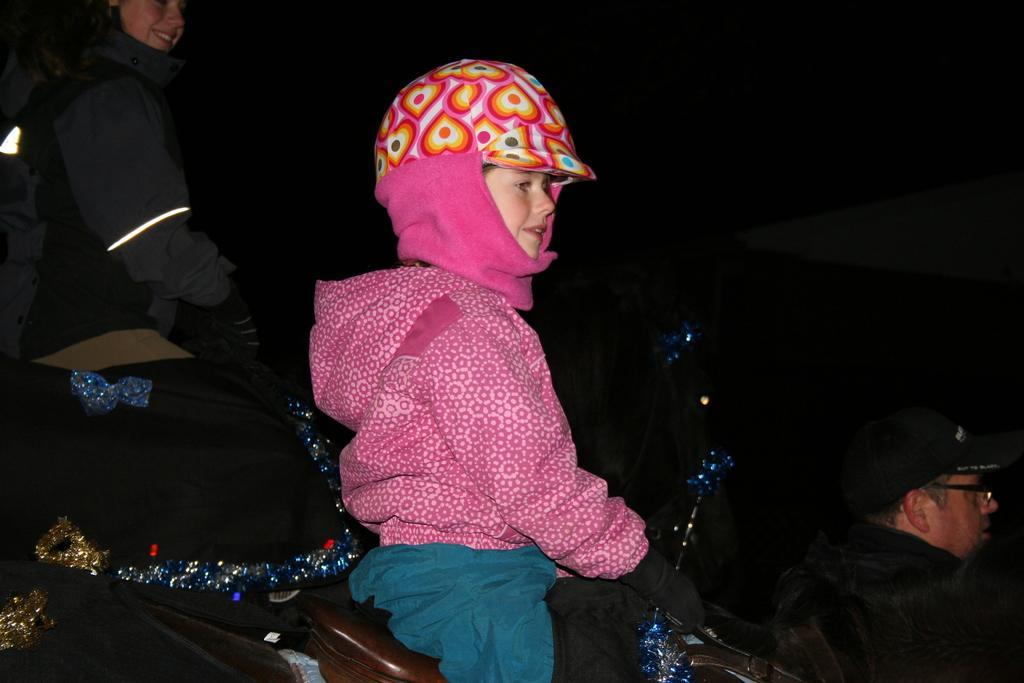Please provide a concise description of this image. In this picture we can see three people, caps, spectacle, gloves, jackets, clothes and some objects and two people are smiling and in the background it is dark. 